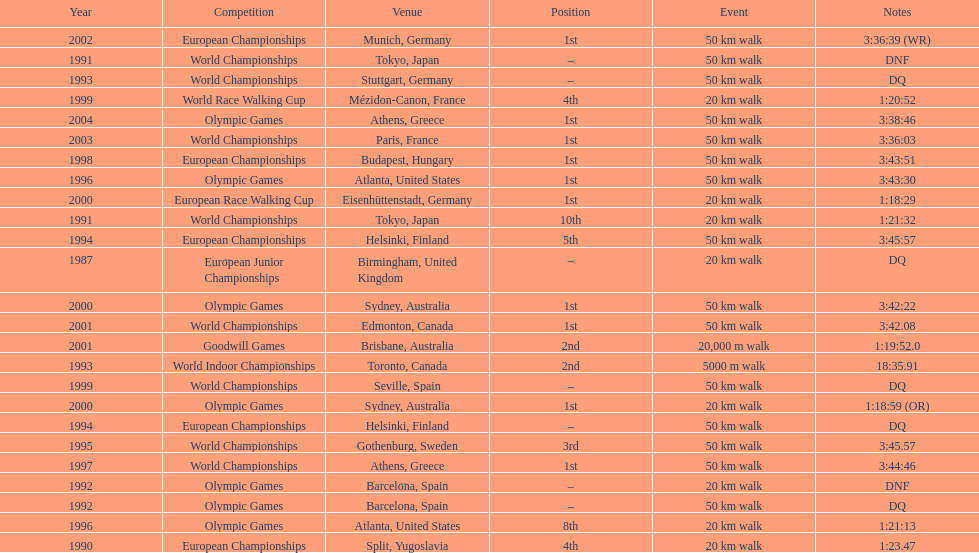How many times was first place listed as the position? 10. 